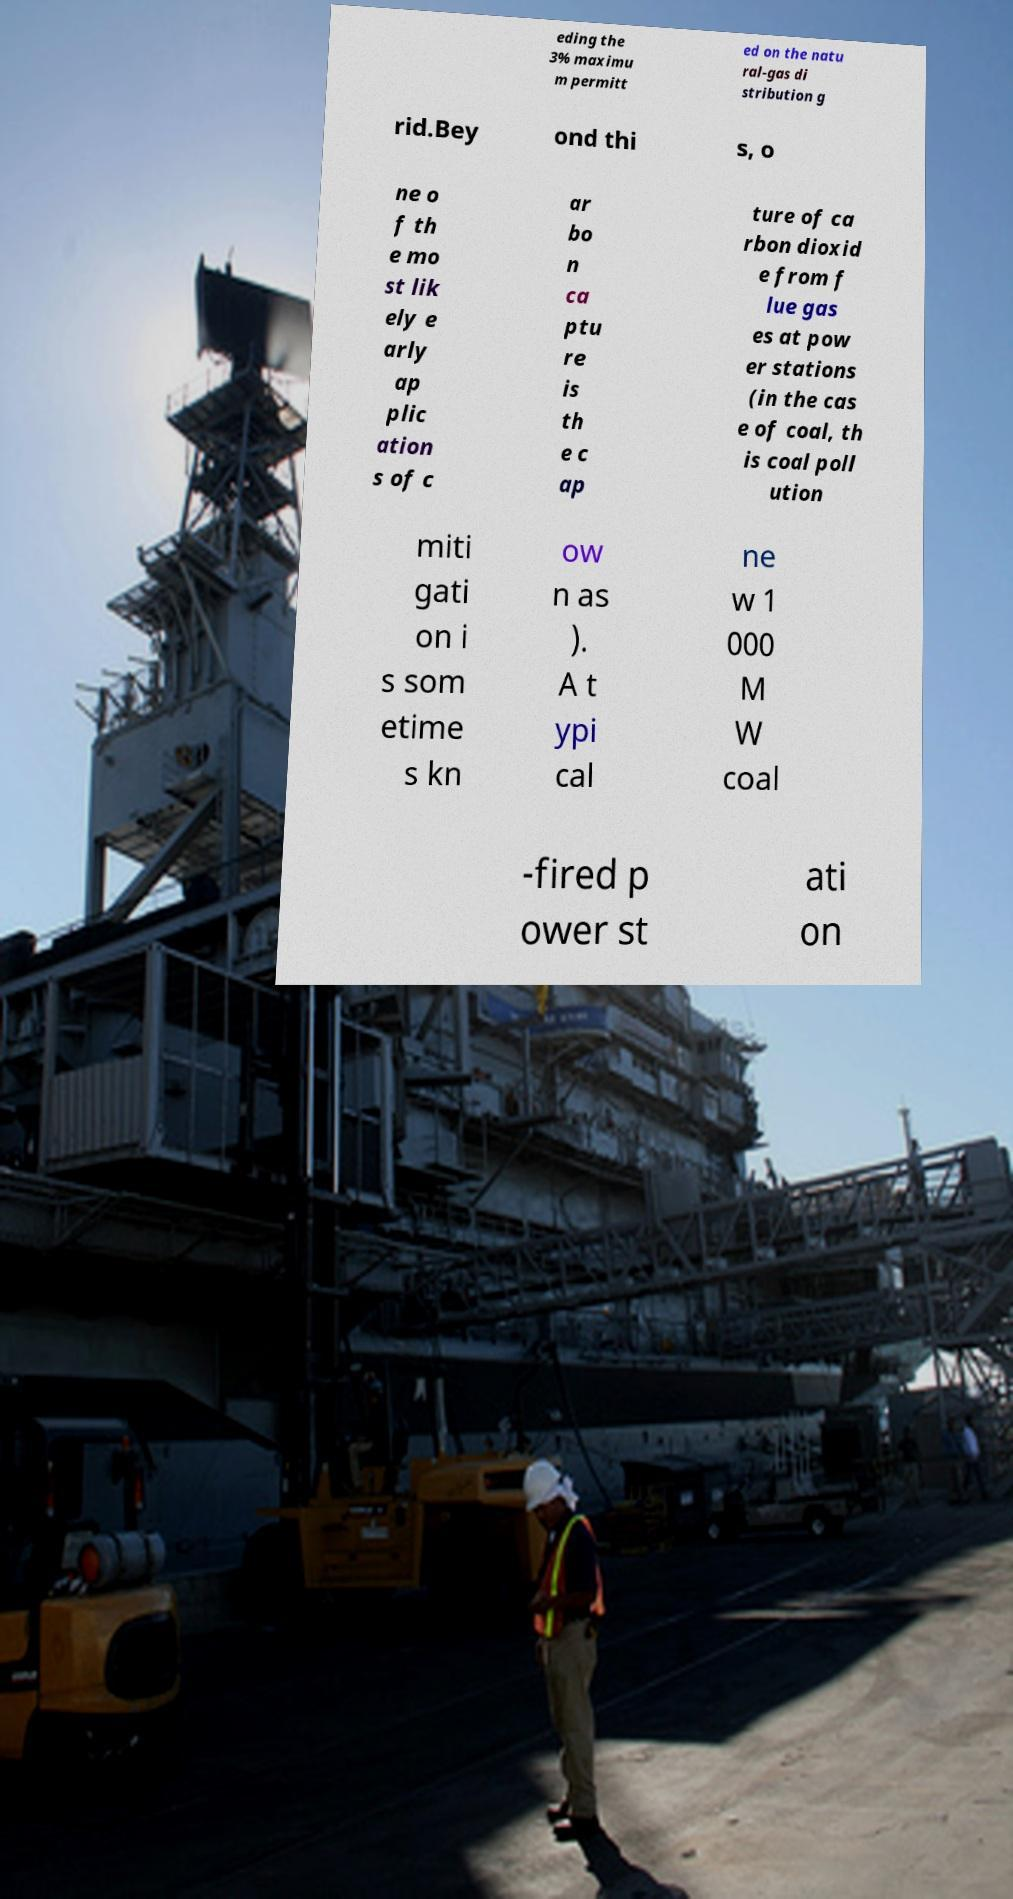Please identify and transcribe the text found in this image. eding the 3% maximu m permitt ed on the natu ral-gas di stribution g rid.Bey ond thi s, o ne o f th e mo st lik ely e arly ap plic ation s of c ar bo n ca ptu re is th e c ap ture of ca rbon dioxid e from f lue gas es at pow er stations (in the cas e of coal, th is coal poll ution miti gati on i s som etime s kn ow n as ). A t ypi cal ne w 1 000 M W coal -fired p ower st ati on 